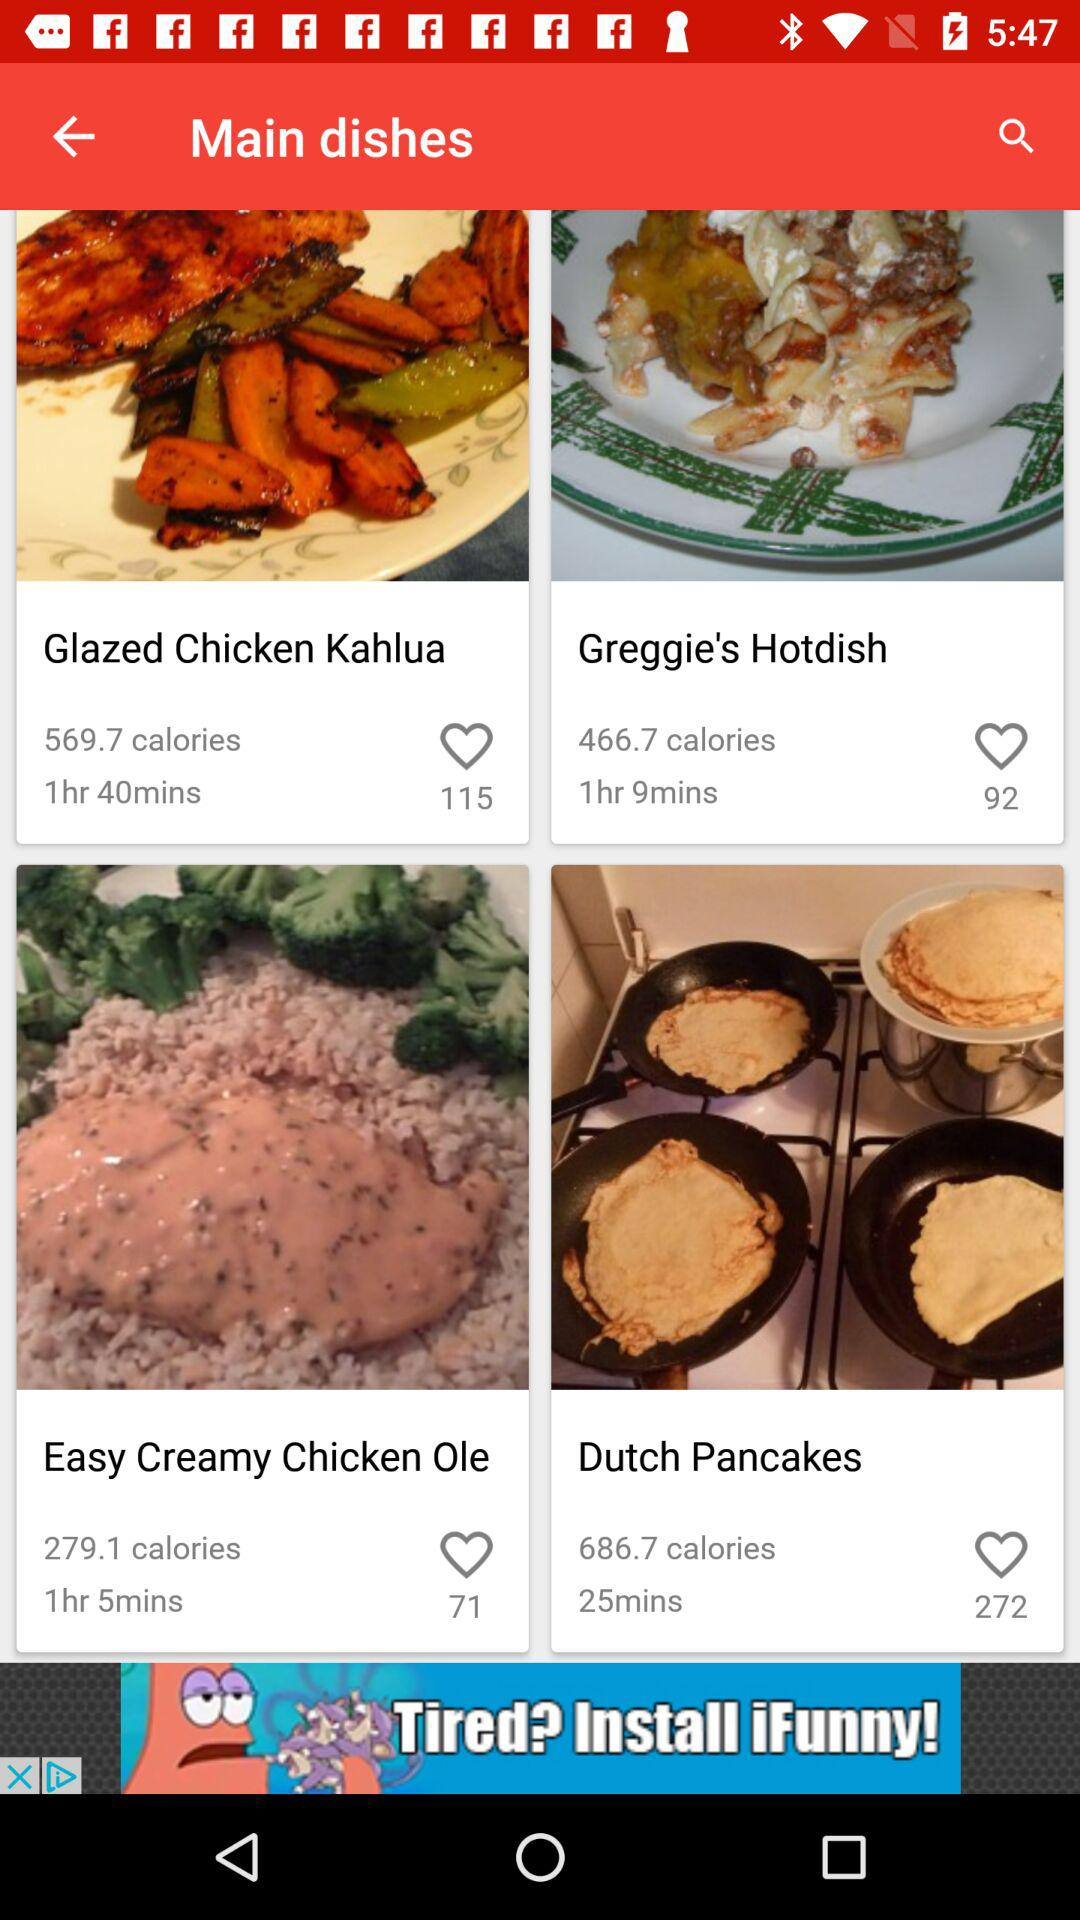How many people liked "Glazed Chicken Kahlua"? "Glazed Chicken Kahlua" was liked by 115 people. 